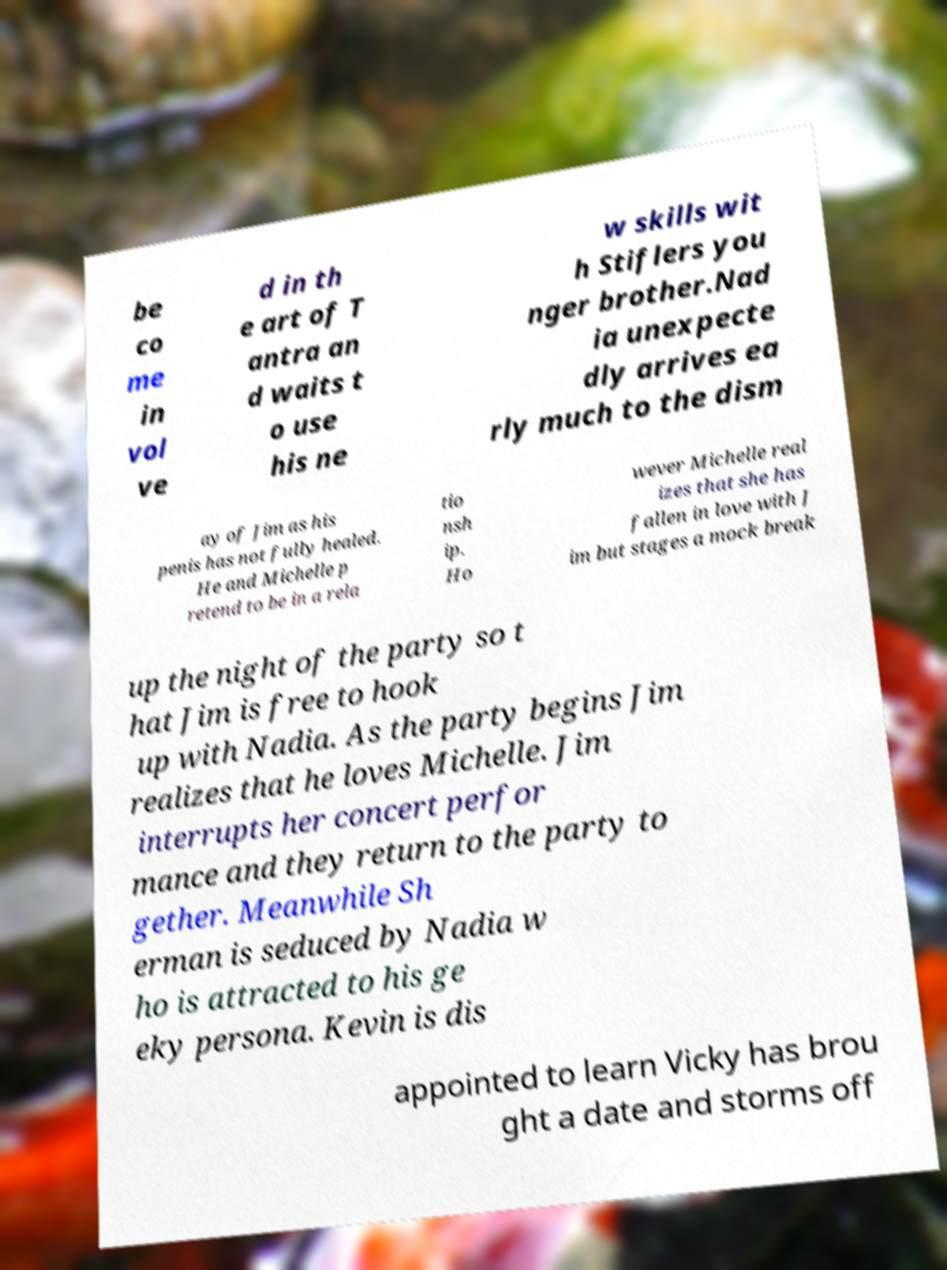I need the written content from this picture converted into text. Can you do that? be co me in vol ve d in th e art of T antra an d waits t o use his ne w skills wit h Stiflers you nger brother.Nad ia unexpecte dly arrives ea rly much to the dism ay of Jim as his penis has not fully healed. He and Michelle p retend to be in a rela tio nsh ip. Ho wever Michelle real izes that she has fallen in love with J im but stages a mock break up the night of the party so t hat Jim is free to hook up with Nadia. As the party begins Jim realizes that he loves Michelle. Jim interrupts her concert perfor mance and they return to the party to gether. Meanwhile Sh erman is seduced by Nadia w ho is attracted to his ge eky persona. Kevin is dis appointed to learn Vicky has brou ght a date and storms off 